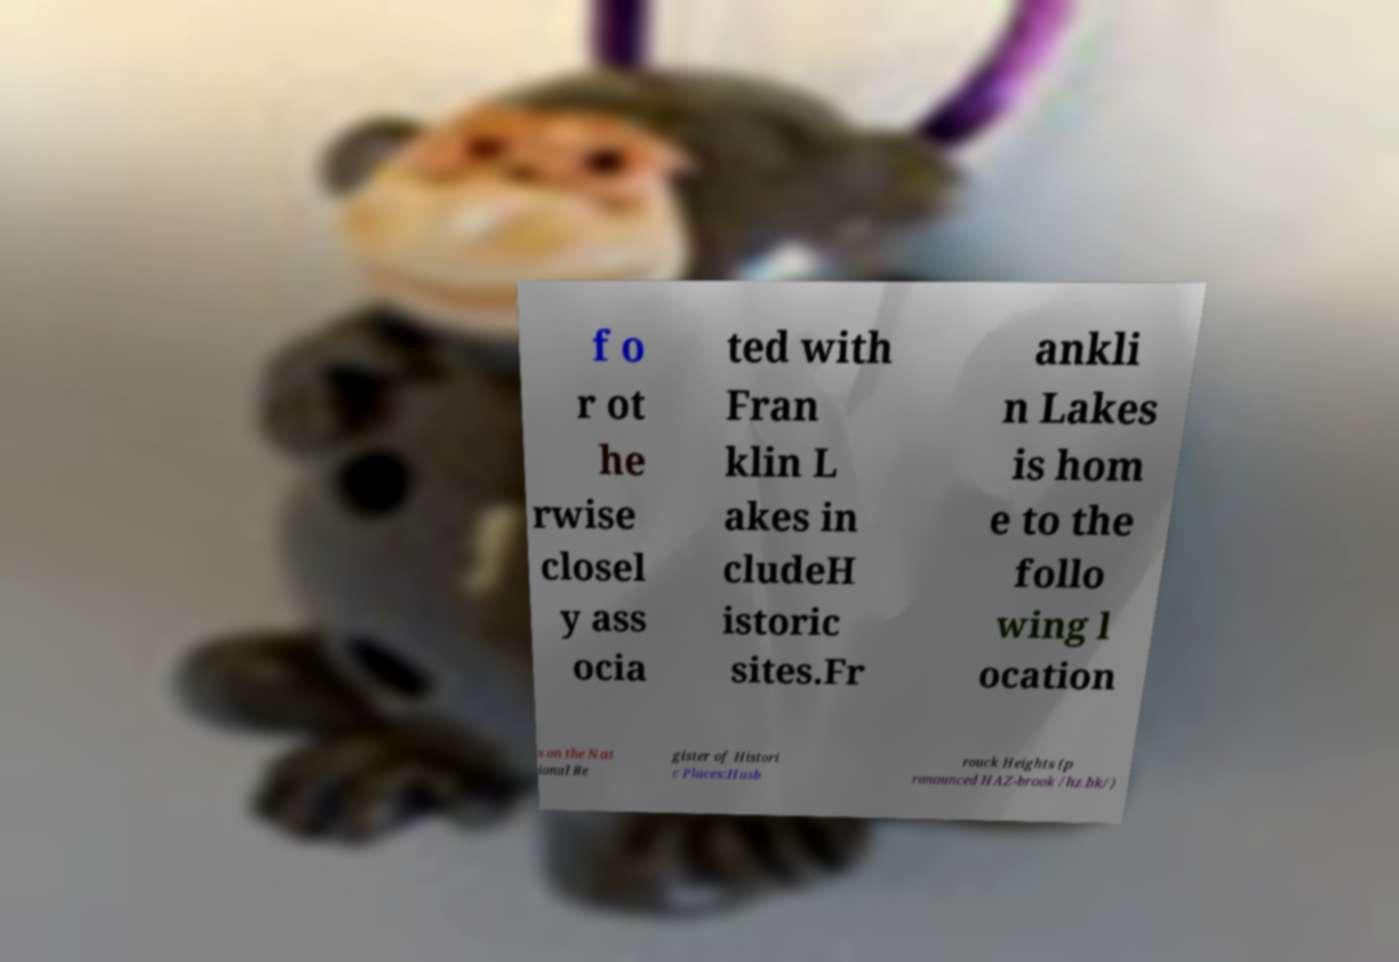Could you extract and type out the text from this image? f o r ot he rwise closel y ass ocia ted with Fran klin L akes in cludeH istoric sites.Fr ankli n Lakes is hom e to the follo wing l ocation s on the Nat ional Re gister of Histori c Places:Hasb rouck Heights (p ronounced HAZ-brook /hz.bk/) 